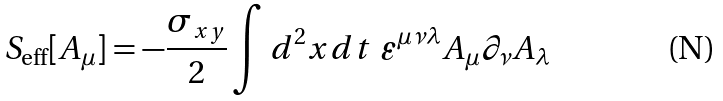<formula> <loc_0><loc_0><loc_500><loc_500>S _ { \text {eff} } [ A _ { \mu } ] = - \frac { \sigma _ { x y } } 2 \int d ^ { 2 } x d t \ \varepsilon ^ { \mu \nu \lambda } A _ { \mu } \partial _ { \nu } A _ { \lambda }</formula> 